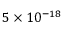Convert formula to latex. <formula><loc_0><loc_0><loc_500><loc_500>5 \times 1 0 ^ { - 1 8 }</formula> 